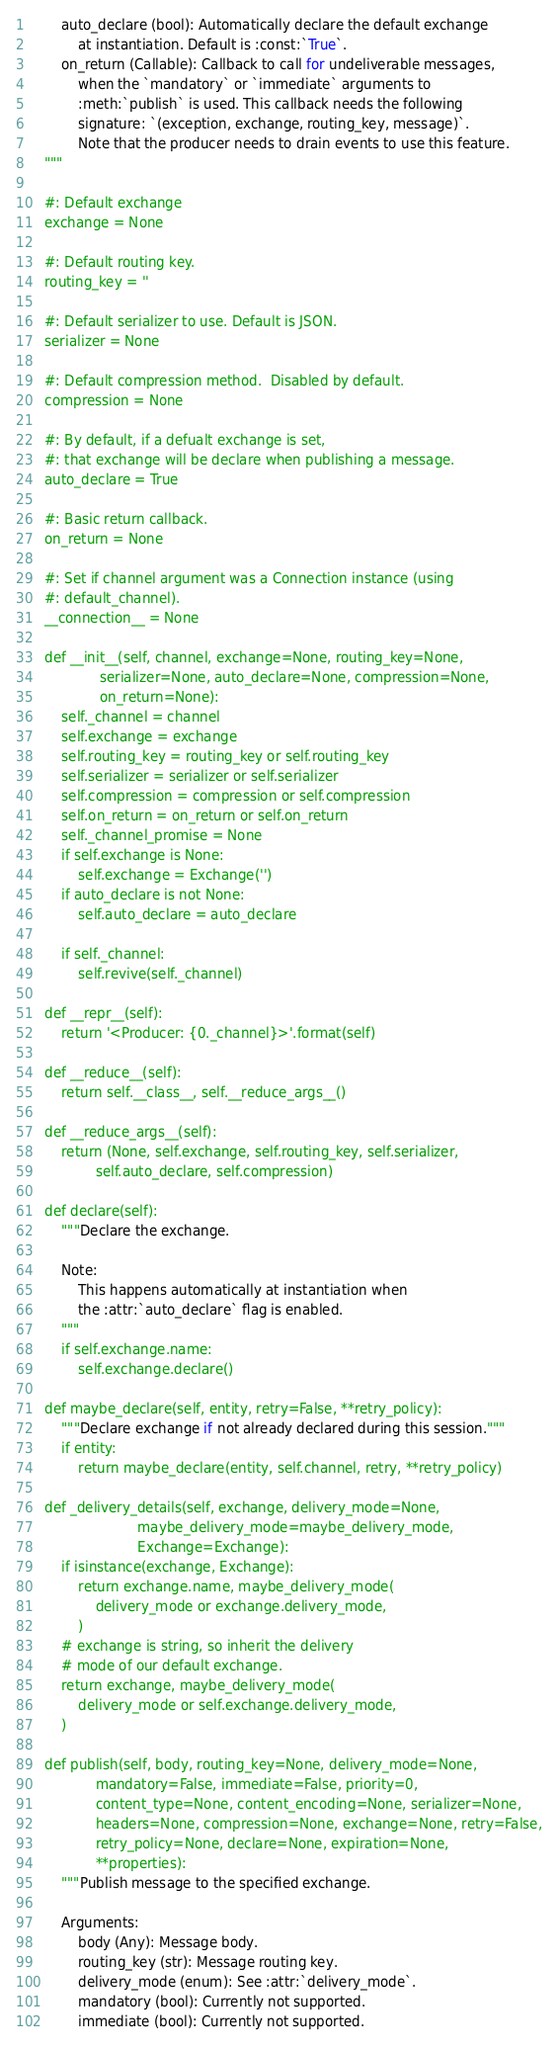<code> <loc_0><loc_0><loc_500><loc_500><_Python_>        auto_declare (bool): Automatically declare the default exchange
            at instantiation. Default is :const:`True`.
        on_return (Callable): Callback to call for undeliverable messages,
            when the `mandatory` or `immediate` arguments to
            :meth:`publish` is used. This callback needs the following
            signature: `(exception, exchange, routing_key, message)`.
            Note that the producer needs to drain events to use this feature.
    """

    #: Default exchange
    exchange = None

    #: Default routing key.
    routing_key = ''

    #: Default serializer to use. Default is JSON.
    serializer = None

    #: Default compression method.  Disabled by default.
    compression = None

    #: By default, if a defualt exchange is set,
    #: that exchange will be declare when publishing a message.
    auto_declare = True

    #: Basic return callback.
    on_return = None

    #: Set if channel argument was a Connection instance (using
    #: default_channel).
    __connection__ = None

    def __init__(self, channel, exchange=None, routing_key=None,
                 serializer=None, auto_declare=None, compression=None,
                 on_return=None):
        self._channel = channel
        self.exchange = exchange
        self.routing_key = routing_key or self.routing_key
        self.serializer = serializer or self.serializer
        self.compression = compression or self.compression
        self.on_return = on_return or self.on_return
        self._channel_promise = None
        if self.exchange is None:
            self.exchange = Exchange('')
        if auto_declare is not None:
            self.auto_declare = auto_declare

        if self._channel:
            self.revive(self._channel)

    def __repr__(self):
        return '<Producer: {0._channel}>'.format(self)

    def __reduce__(self):
        return self.__class__, self.__reduce_args__()

    def __reduce_args__(self):
        return (None, self.exchange, self.routing_key, self.serializer,
                self.auto_declare, self.compression)

    def declare(self):
        """Declare the exchange.

        Note:
            This happens automatically at instantiation when
            the :attr:`auto_declare` flag is enabled.
        """
        if self.exchange.name:
            self.exchange.declare()

    def maybe_declare(self, entity, retry=False, **retry_policy):
        """Declare exchange if not already declared during this session."""
        if entity:
            return maybe_declare(entity, self.channel, retry, **retry_policy)

    def _delivery_details(self, exchange, delivery_mode=None,
                          maybe_delivery_mode=maybe_delivery_mode,
                          Exchange=Exchange):
        if isinstance(exchange, Exchange):
            return exchange.name, maybe_delivery_mode(
                delivery_mode or exchange.delivery_mode,
            )
        # exchange is string, so inherit the delivery
        # mode of our default exchange.
        return exchange, maybe_delivery_mode(
            delivery_mode or self.exchange.delivery_mode,
        )

    def publish(self, body, routing_key=None, delivery_mode=None,
                mandatory=False, immediate=False, priority=0,
                content_type=None, content_encoding=None, serializer=None,
                headers=None, compression=None, exchange=None, retry=False,
                retry_policy=None, declare=None, expiration=None,
                **properties):
        """Publish message to the specified exchange.

        Arguments:
            body (Any): Message body.
            routing_key (str): Message routing key.
            delivery_mode (enum): See :attr:`delivery_mode`.
            mandatory (bool): Currently not supported.
            immediate (bool): Currently not supported.</code> 